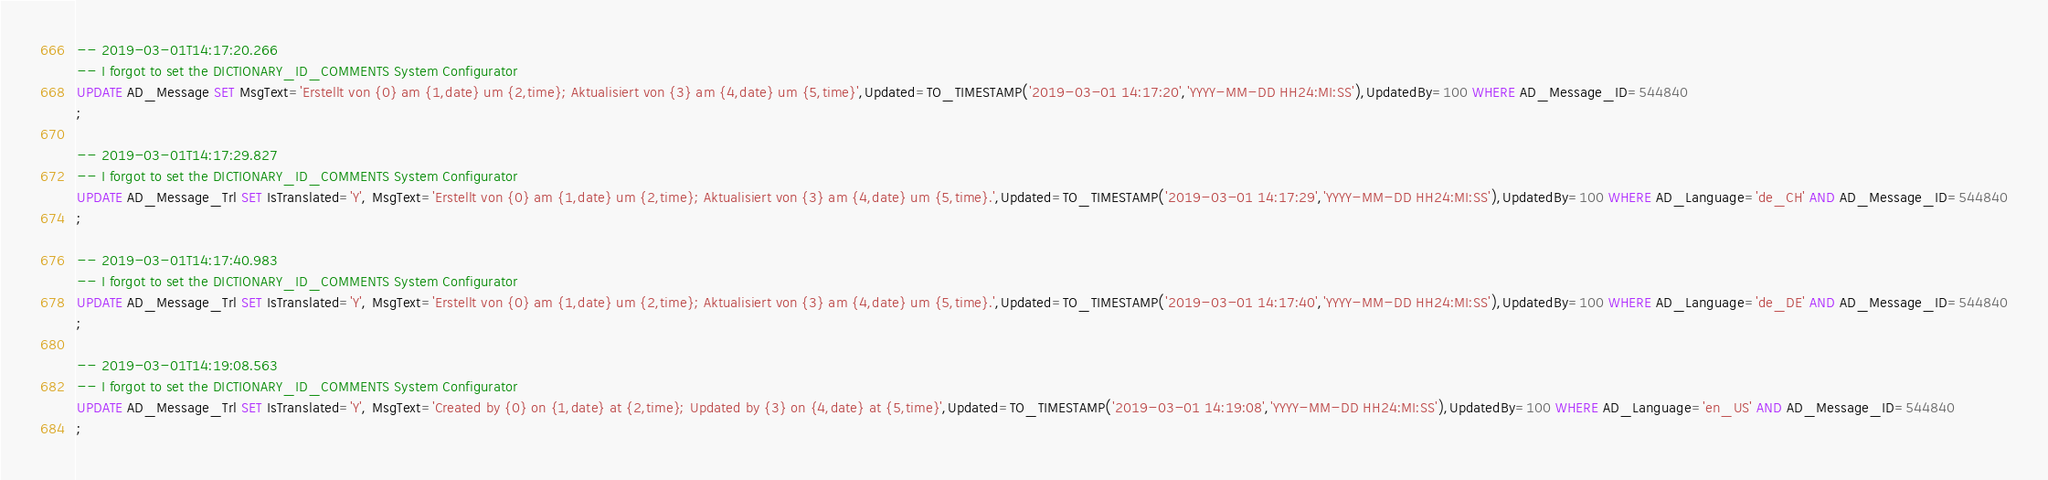Convert code to text. <code><loc_0><loc_0><loc_500><loc_500><_SQL_>-- 2019-03-01T14:17:20.266
-- I forgot to set the DICTIONARY_ID_COMMENTS System Configurator
UPDATE AD_Message SET MsgText='Erstellt von {0} am {1,date} um {2,time}; Aktualisiert von {3} am {4,date} um {5,time}',Updated=TO_TIMESTAMP('2019-03-01 14:17:20','YYYY-MM-DD HH24:MI:SS'),UpdatedBy=100 WHERE AD_Message_ID=544840
;

-- 2019-03-01T14:17:29.827
-- I forgot to set the DICTIONARY_ID_COMMENTS System Configurator
UPDATE AD_Message_Trl SET IsTranslated='Y', MsgText='Erstellt von {0} am {1,date} um {2,time}; Aktualisiert von {3} am {4,date} um {5,time}.',Updated=TO_TIMESTAMP('2019-03-01 14:17:29','YYYY-MM-DD HH24:MI:SS'),UpdatedBy=100 WHERE AD_Language='de_CH' AND AD_Message_ID=544840
;

-- 2019-03-01T14:17:40.983
-- I forgot to set the DICTIONARY_ID_COMMENTS System Configurator
UPDATE AD_Message_Trl SET IsTranslated='Y', MsgText='Erstellt von {0} am {1,date} um {2,time}; Aktualisiert von {3} am {4,date} um {5,time}.',Updated=TO_TIMESTAMP('2019-03-01 14:17:40','YYYY-MM-DD HH24:MI:SS'),UpdatedBy=100 WHERE AD_Language='de_DE' AND AD_Message_ID=544840
;

-- 2019-03-01T14:19:08.563
-- I forgot to set the DICTIONARY_ID_COMMENTS System Configurator
UPDATE AD_Message_Trl SET IsTranslated='Y', MsgText='Created by {0} on {1,date} at {2,time}; Updated by {3} on {4,date} at {5,time}',Updated=TO_TIMESTAMP('2019-03-01 14:19:08','YYYY-MM-DD HH24:MI:SS'),UpdatedBy=100 WHERE AD_Language='en_US' AND AD_Message_ID=544840
;

</code> 